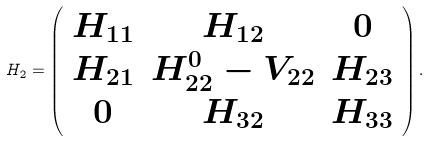<formula> <loc_0><loc_0><loc_500><loc_500>H _ { 2 } = \left ( \begin{array} { c c c } H _ { 1 1 } & H _ { 1 2 } & 0 \\ H _ { 2 1 } & H _ { 2 2 } ^ { 0 } - V _ { 2 2 } & H _ { 2 3 } \\ 0 & H _ { 3 2 } & H _ { 3 3 } \\ \end{array} \right ) .</formula> 